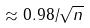<formula> <loc_0><loc_0><loc_500><loc_500>\approx 0 . 9 8 / \sqrt { n }</formula> 